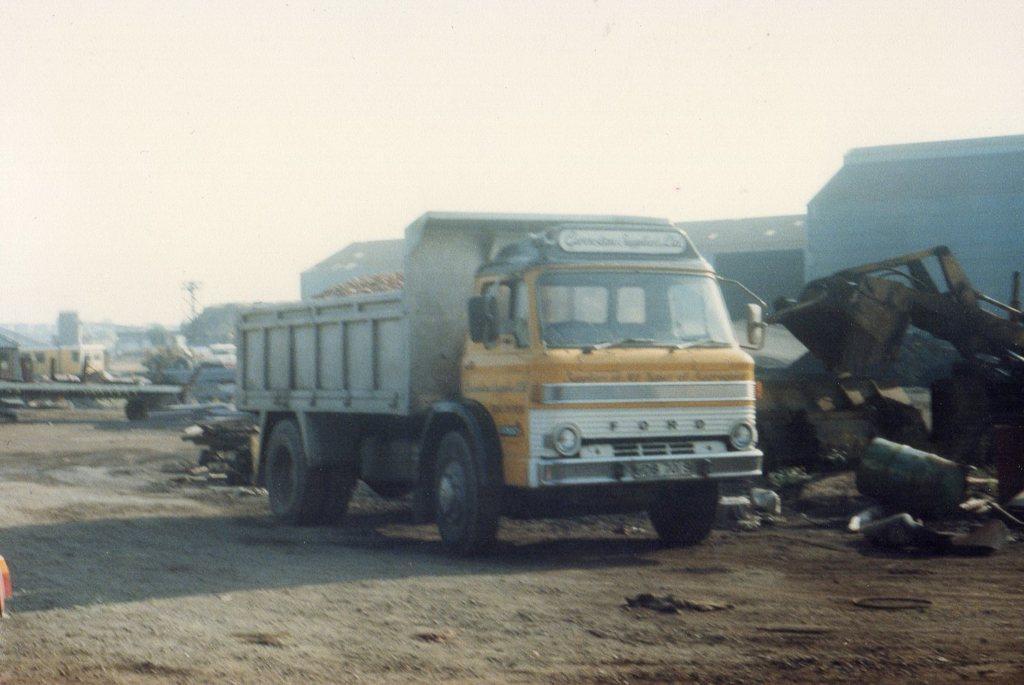Can you describe this image briefly? Here we can see vehicles, trash, drum, and walls. In the background there is sky. 